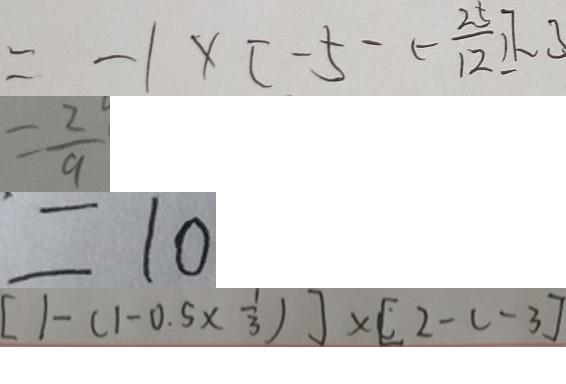<formula> <loc_0><loc_0><loc_500><loc_500>= - 1 \times [ - 5 - ( - \frac { 2 5 } { 1 2 } ) ] - 3 
 = \frac { 2 } { 9 } 
 = 1 0 
 [ 1 - ( 1 - 0 . 5 \times \frac { 1 } { 3 } ) ] \times [ 2 - c - 3 ]</formula> 